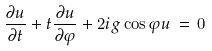Convert formula to latex. <formula><loc_0><loc_0><loc_500><loc_500>\frac { \partial u } { \partial t } + t \frac { \partial u } { \partial \varphi } + 2 i g \cos \varphi u \, = \, 0</formula> 